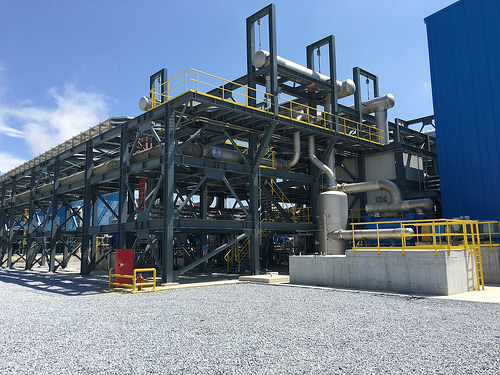<image>
Is there a sky behind the land? Yes. From this viewpoint, the sky is positioned behind the land, with the land partially or fully occluding the sky. 